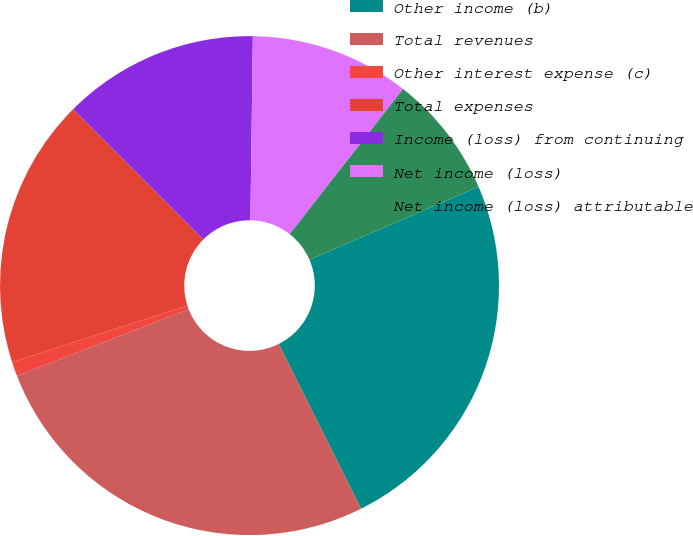<chart> <loc_0><loc_0><loc_500><loc_500><pie_chart><fcel>Other income (b)<fcel>Total revenues<fcel>Other interest expense (c)<fcel>Total expenses<fcel>Income (loss) from continuing<fcel>Net income (loss)<fcel>Net income (loss) attributable<nl><fcel>24.11%<fcel>26.49%<fcel>0.93%<fcel>17.47%<fcel>12.71%<fcel>10.34%<fcel>7.96%<nl></chart> 